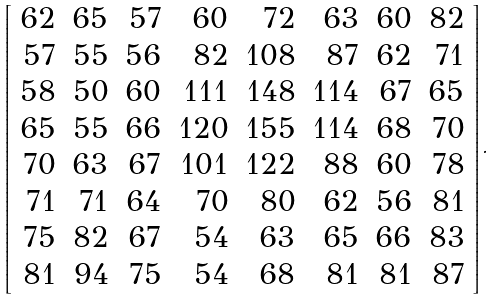<formula> <loc_0><loc_0><loc_500><loc_500>\left [ { \begin{array} { r r r r r r r r } { 6 2 } & { 6 5 } & { 5 7 } & { 6 0 } & { 7 2 } & { 6 3 } & { 6 0 } & { 8 2 } \\ { 5 7 } & { 5 5 } & { 5 6 } & { 8 2 } & { 1 0 8 } & { 8 7 } & { 6 2 } & { 7 1 } \\ { 5 8 } & { 5 0 } & { 6 0 } & { 1 1 1 } & { 1 4 8 } & { 1 1 4 } & { 6 7 } & { 6 5 } \\ { 6 5 } & { 5 5 } & { 6 6 } & { 1 2 0 } & { 1 5 5 } & { 1 1 4 } & { 6 8 } & { 7 0 } \\ { 7 0 } & { 6 3 } & { 6 7 } & { 1 0 1 } & { 1 2 2 } & { 8 8 } & { 6 0 } & { 7 8 } \\ { 7 1 } & { 7 1 } & { 6 4 } & { 7 0 } & { 8 0 } & { 6 2 } & { 5 6 } & { 8 1 } \\ { 7 5 } & { 8 2 } & { 6 7 } & { 5 4 } & { 6 3 } & { 6 5 } & { 6 6 } & { 8 3 } \\ { 8 1 } & { 9 4 } & { 7 5 } & { 5 4 } & { 6 8 } & { 8 1 } & { 8 1 } & { 8 7 } \end{array} } \right ] .</formula> 